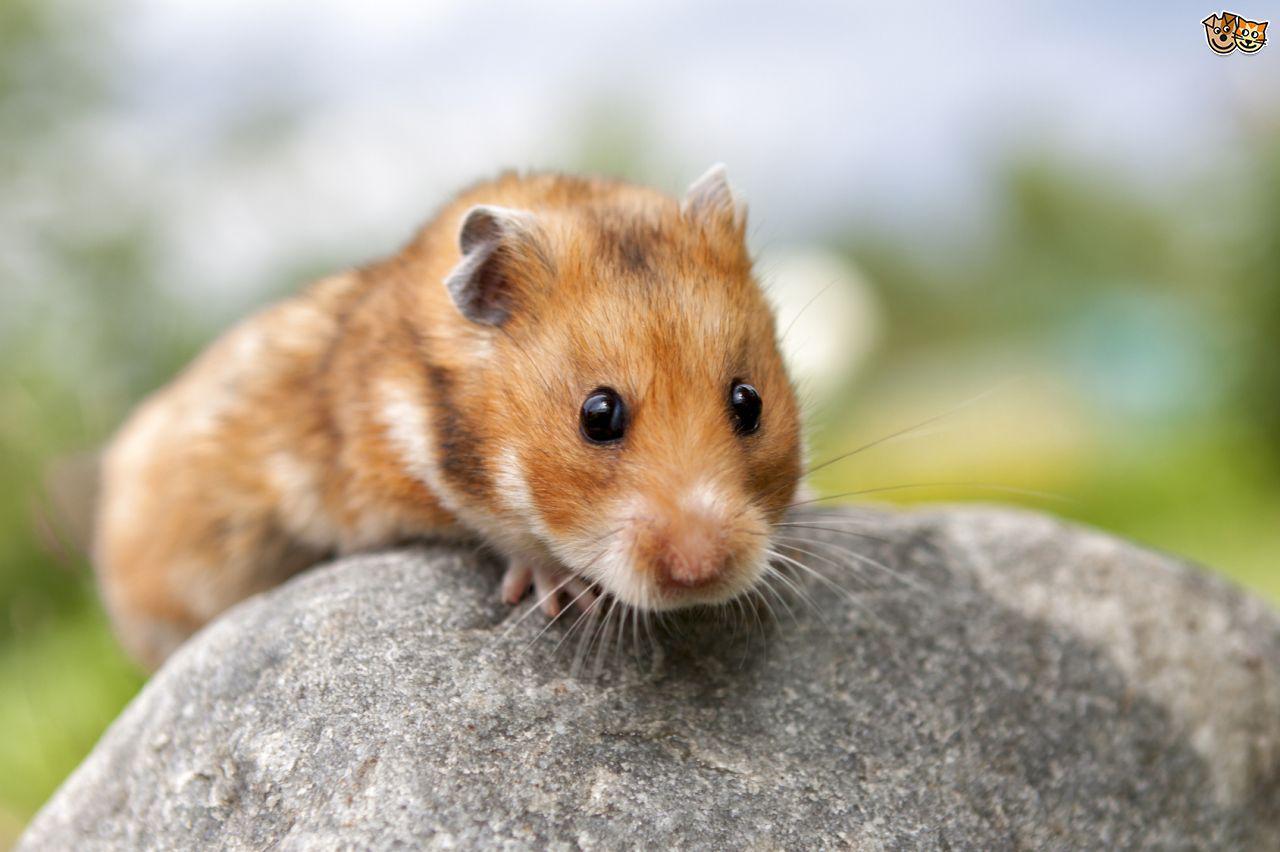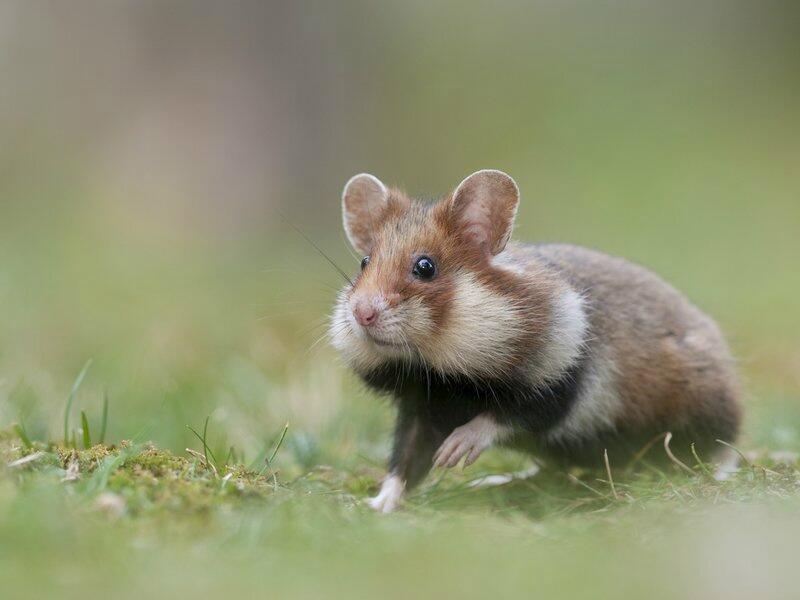The first image is the image on the left, the second image is the image on the right. For the images displayed, is the sentence "One of the animals is sitting on a rock." factually correct? Answer yes or no. Yes. 